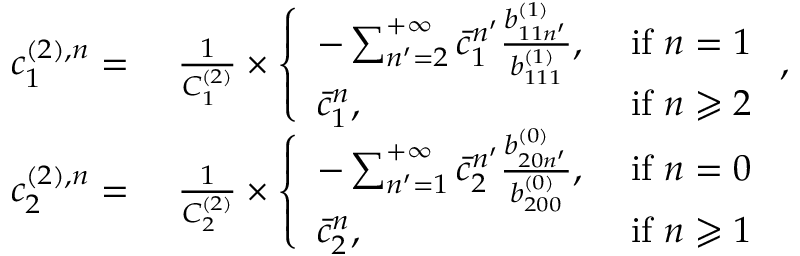<formula> <loc_0><loc_0><loc_500><loc_500>\begin{array} { r l } { c _ { 1 } ^ { ( 2 ) , n } = } & { \ \frac { 1 } { C _ { 1 } ^ { ( 2 ) } } \times \left \{ \begin{array} { l l } { - \sum _ { n ^ { \prime } = 2 } ^ { + \infty } \bar { c } _ { 1 } ^ { n ^ { \prime } } \frac { b _ { 1 1 n ^ { \prime } } ^ { ( 1 ) } } { b _ { 1 1 1 } ^ { ( 1 ) } } , } & { i f n = 1 } \\ { \bar { c } _ { 1 } ^ { n } , } & { i f n \geqslant 2 } \end{array} , } \\ { c _ { 2 } ^ { ( 2 ) , n } = } & { \ \frac { 1 } { C _ { 2 } ^ { ( 2 ) } } \times \left \{ \begin{array} { l l } { - \sum _ { n ^ { \prime } = 1 } ^ { + \infty } \bar { c } _ { 2 } ^ { n ^ { \prime } } \frac { b _ { 2 0 n ^ { \prime } } ^ { ( 0 ) } } { b _ { 2 0 0 } ^ { ( 0 ) } } , } & { i f n = 0 } \\ { \bar { c } _ { 2 } ^ { n } , } & { i f n \geqslant 1 } \end{array} } \end{array}</formula> 